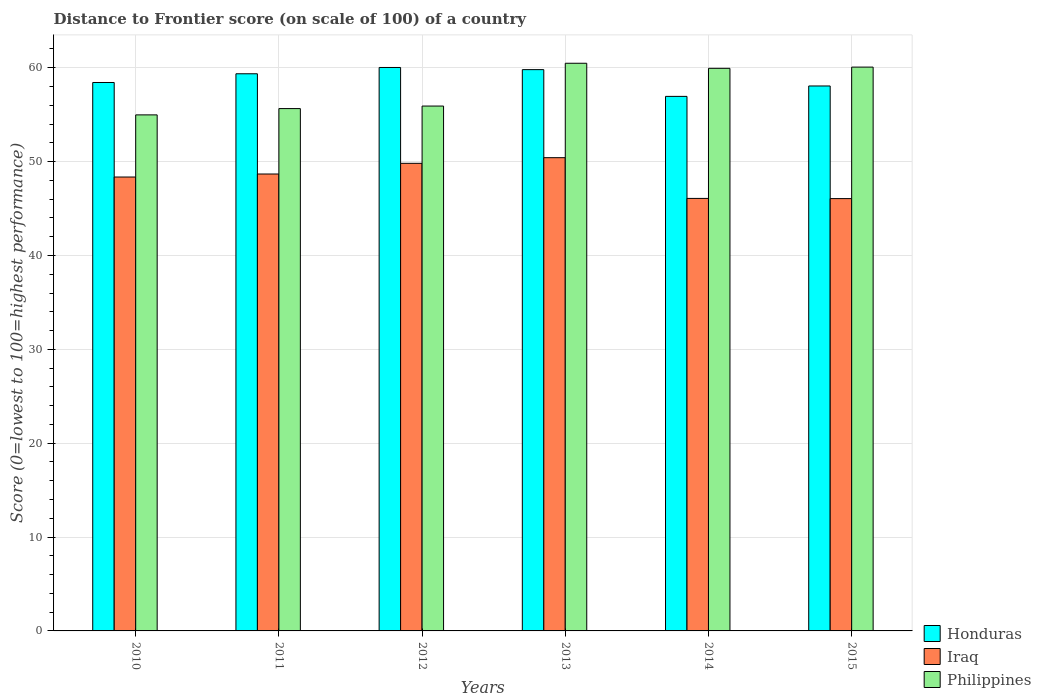How many different coloured bars are there?
Keep it short and to the point. 3. What is the distance to frontier score of in Philippines in 2015?
Your response must be concise. 60.07. Across all years, what is the maximum distance to frontier score of in Iraq?
Your answer should be compact. 50.42. Across all years, what is the minimum distance to frontier score of in Iraq?
Provide a succinct answer. 46.06. In which year was the distance to frontier score of in Iraq maximum?
Provide a short and direct response. 2013. In which year was the distance to frontier score of in Honduras minimum?
Offer a very short reply. 2014. What is the total distance to frontier score of in Philippines in the graph?
Provide a succinct answer. 347.04. What is the difference between the distance to frontier score of in Iraq in 2010 and that in 2013?
Your response must be concise. -2.06. What is the difference between the distance to frontier score of in Philippines in 2011 and the distance to frontier score of in Iraq in 2012?
Keep it short and to the point. 5.83. What is the average distance to frontier score of in Honduras per year?
Offer a terse response. 58.77. In the year 2013, what is the difference between the distance to frontier score of in Iraq and distance to frontier score of in Honduras?
Provide a short and direct response. -9.38. What is the ratio of the distance to frontier score of in Honduras in 2010 to that in 2011?
Make the answer very short. 0.98. Is the distance to frontier score of in Honduras in 2011 less than that in 2015?
Make the answer very short. No. Is the difference between the distance to frontier score of in Iraq in 2010 and 2015 greater than the difference between the distance to frontier score of in Honduras in 2010 and 2015?
Make the answer very short. Yes. What is the difference between the highest and the second highest distance to frontier score of in Philippines?
Provide a short and direct response. 0.41. What does the 2nd bar from the left in 2014 represents?
Provide a short and direct response. Iraq. What does the 2nd bar from the right in 2010 represents?
Ensure brevity in your answer.  Iraq. Are all the bars in the graph horizontal?
Make the answer very short. No. Are the values on the major ticks of Y-axis written in scientific E-notation?
Keep it short and to the point. No. Does the graph contain any zero values?
Keep it short and to the point. No. Where does the legend appear in the graph?
Keep it short and to the point. Bottom right. What is the title of the graph?
Keep it short and to the point. Distance to Frontier score (on scale of 100) of a country. What is the label or title of the Y-axis?
Make the answer very short. Score (0=lowest to 100=highest performance). What is the Score (0=lowest to 100=highest performance) in Honduras in 2010?
Offer a very short reply. 58.43. What is the Score (0=lowest to 100=highest performance) in Iraq in 2010?
Provide a succinct answer. 48.36. What is the Score (0=lowest to 100=highest performance) of Philippines in 2010?
Provide a short and direct response. 54.98. What is the Score (0=lowest to 100=highest performance) in Honduras in 2011?
Offer a terse response. 59.36. What is the Score (0=lowest to 100=highest performance) in Iraq in 2011?
Your answer should be compact. 48.68. What is the Score (0=lowest to 100=highest performance) of Philippines in 2011?
Provide a succinct answer. 55.65. What is the Score (0=lowest to 100=highest performance) of Honduras in 2012?
Ensure brevity in your answer.  60.03. What is the Score (0=lowest to 100=highest performance) in Iraq in 2012?
Offer a terse response. 49.82. What is the Score (0=lowest to 100=highest performance) in Philippines in 2012?
Offer a very short reply. 55.92. What is the Score (0=lowest to 100=highest performance) in Honduras in 2013?
Your response must be concise. 59.8. What is the Score (0=lowest to 100=highest performance) of Iraq in 2013?
Offer a very short reply. 50.42. What is the Score (0=lowest to 100=highest performance) in Philippines in 2013?
Your answer should be very brief. 60.48. What is the Score (0=lowest to 100=highest performance) of Honduras in 2014?
Keep it short and to the point. 56.95. What is the Score (0=lowest to 100=highest performance) of Iraq in 2014?
Provide a succinct answer. 46.08. What is the Score (0=lowest to 100=highest performance) of Philippines in 2014?
Your answer should be very brief. 59.94. What is the Score (0=lowest to 100=highest performance) in Honduras in 2015?
Provide a short and direct response. 58.06. What is the Score (0=lowest to 100=highest performance) in Iraq in 2015?
Provide a short and direct response. 46.06. What is the Score (0=lowest to 100=highest performance) in Philippines in 2015?
Make the answer very short. 60.07. Across all years, what is the maximum Score (0=lowest to 100=highest performance) of Honduras?
Your answer should be very brief. 60.03. Across all years, what is the maximum Score (0=lowest to 100=highest performance) of Iraq?
Provide a succinct answer. 50.42. Across all years, what is the maximum Score (0=lowest to 100=highest performance) of Philippines?
Your response must be concise. 60.48. Across all years, what is the minimum Score (0=lowest to 100=highest performance) in Honduras?
Keep it short and to the point. 56.95. Across all years, what is the minimum Score (0=lowest to 100=highest performance) of Iraq?
Ensure brevity in your answer.  46.06. Across all years, what is the minimum Score (0=lowest to 100=highest performance) in Philippines?
Provide a short and direct response. 54.98. What is the total Score (0=lowest to 100=highest performance) of Honduras in the graph?
Your response must be concise. 352.63. What is the total Score (0=lowest to 100=highest performance) of Iraq in the graph?
Your answer should be very brief. 289.42. What is the total Score (0=lowest to 100=highest performance) of Philippines in the graph?
Offer a very short reply. 347.04. What is the difference between the Score (0=lowest to 100=highest performance) of Honduras in 2010 and that in 2011?
Your answer should be very brief. -0.93. What is the difference between the Score (0=lowest to 100=highest performance) in Iraq in 2010 and that in 2011?
Offer a terse response. -0.32. What is the difference between the Score (0=lowest to 100=highest performance) of Philippines in 2010 and that in 2011?
Your response must be concise. -0.67. What is the difference between the Score (0=lowest to 100=highest performance) of Honduras in 2010 and that in 2012?
Keep it short and to the point. -1.6. What is the difference between the Score (0=lowest to 100=highest performance) of Iraq in 2010 and that in 2012?
Offer a terse response. -1.46. What is the difference between the Score (0=lowest to 100=highest performance) of Philippines in 2010 and that in 2012?
Your answer should be very brief. -0.94. What is the difference between the Score (0=lowest to 100=highest performance) in Honduras in 2010 and that in 2013?
Provide a short and direct response. -1.37. What is the difference between the Score (0=lowest to 100=highest performance) of Iraq in 2010 and that in 2013?
Give a very brief answer. -2.06. What is the difference between the Score (0=lowest to 100=highest performance) of Honduras in 2010 and that in 2014?
Offer a terse response. 1.48. What is the difference between the Score (0=lowest to 100=highest performance) in Iraq in 2010 and that in 2014?
Keep it short and to the point. 2.28. What is the difference between the Score (0=lowest to 100=highest performance) in Philippines in 2010 and that in 2014?
Your response must be concise. -4.96. What is the difference between the Score (0=lowest to 100=highest performance) in Honduras in 2010 and that in 2015?
Make the answer very short. 0.37. What is the difference between the Score (0=lowest to 100=highest performance) of Philippines in 2010 and that in 2015?
Provide a short and direct response. -5.09. What is the difference between the Score (0=lowest to 100=highest performance) of Honduras in 2011 and that in 2012?
Offer a very short reply. -0.67. What is the difference between the Score (0=lowest to 100=highest performance) in Iraq in 2011 and that in 2012?
Offer a terse response. -1.14. What is the difference between the Score (0=lowest to 100=highest performance) in Philippines in 2011 and that in 2012?
Your response must be concise. -0.27. What is the difference between the Score (0=lowest to 100=highest performance) in Honduras in 2011 and that in 2013?
Your response must be concise. -0.44. What is the difference between the Score (0=lowest to 100=highest performance) of Iraq in 2011 and that in 2013?
Offer a terse response. -1.74. What is the difference between the Score (0=lowest to 100=highest performance) of Philippines in 2011 and that in 2013?
Give a very brief answer. -4.83. What is the difference between the Score (0=lowest to 100=highest performance) in Honduras in 2011 and that in 2014?
Provide a short and direct response. 2.41. What is the difference between the Score (0=lowest to 100=highest performance) in Philippines in 2011 and that in 2014?
Offer a very short reply. -4.29. What is the difference between the Score (0=lowest to 100=highest performance) of Honduras in 2011 and that in 2015?
Offer a very short reply. 1.3. What is the difference between the Score (0=lowest to 100=highest performance) of Iraq in 2011 and that in 2015?
Offer a very short reply. 2.62. What is the difference between the Score (0=lowest to 100=highest performance) of Philippines in 2011 and that in 2015?
Offer a very short reply. -4.42. What is the difference between the Score (0=lowest to 100=highest performance) of Honduras in 2012 and that in 2013?
Make the answer very short. 0.23. What is the difference between the Score (0=lowest to 100=highest performance) of Iraq in 2012 and that in 2013?
Your response must be concise. -0.6. What is the difference between the Score (0=lowest to 100=highest performance) in Philippines in 2012 and that in 2013?
Keep it short and to the point. -4.56. What is the difference between the Score (0=lowest to 100=highest performance) of Honduras in 2012 and that in 2014?
Provide a short and direct response. 3.08. What is the difference between the Score (0=lowest to 100=highest performance) in Iraq in 2012 and that in 2014?
Make the answer very short. 3.74. What is the difference between the Score (0=lowest to 100=highest performance) of Philippines in 2012 and that in 2014?
Provide a succinct answer. -4.02. What is the difference between the Score (0=lowest to 100=highest performance) in Honduras in 2012 and that in 2015?
Your answer should be compact. 1.97. What is the difference between the Score (0=lowest to 100=highest performance) of Iraq in 2012 and that in 2015?
Make the answer very short. 3.76. What is the difference between the Score (0=lowest to 100=highest performance) in Philippines in 2012 and that in 2015?
Your answer should be compact. -4.15. What is the difference between the Score (0=lowest to 100=highest performance) of Honduras in 2013 and that in 2014?
Your response must be concise. 2.85. What is the difference between the Score (0=lowest to 100=highest performance) of Iraq in 2013 and that in 2014?
Offer a terse response. 4.34. What is the difference between the Score (0=lowest to 100=highest performance) of Philippines in 2013 and that in 2014?
Make the answer very short. 0.54. What is the difference between the Score (0=lowest to 100=highest performance) of Honduras in 2013 and that in 2015?
Provide a short and direct response. 1.74. What is the difference between the Score (0=lowest to 100=highest performance) in Iraq in 2013 and that in 2015?
Offer a terse response. 4.36. What is the difference between the Score (0=lowest to 100=highest performance) of Philippines in 2013 and that in 2015?
Give a very brief answer. 0.41. What is the difference between the Score (0=lowest to 100=highest performance) in Honduras in 2014 and that in 2015?
Ensure brevity in your answer.  -1.11. What is the difference between the Score (0=lowest to 100=highest performance) of Iraq in 2014 and that in 2015?
Ensure brevity in your answer.  0.02. What is the difference between the Score (0=lowest to 100=highest performance) in Philippines in 2014 and that in 2015?
Your response must be concise. -0.13. What is the difference between the Score (0=lowest to 100=highest performance) in Honduras in 2010 and the Score (0=lowest to 100=highest performance) in Iraq in 2011?
Ensure brevity in your answer.  9.75. What is the difference between the Score (0=lowest to 100=highest performance) of Honduras in 2010 and the Score (0=lowest to 100=highest performance) of Philippines in 2011?
Provide a short and direct response. 2.78. What is the difference between the Score (0=lowest to 100=highest performance) of Iraq in 2010 and the Score (0=lowest to 100=highest performance) of Philippines in 2011?
Provide a succinct answer. -7.29. What is the difference between the Score (0=lowest to 100=highest performance) of Honduras in 2010 and the Score (0=lowest to 100=highest performance) of Iraq in 2012?
Keep it short and to the point. 8.61. What is the difference between the Score (0=lowest to 100=highest performance) of Honduras in 2010 and the Score (0=lowest to 100=highest performance) of Philippines in 2012?
Your response must be concise. 2.51. What is the difference between the Score (0=lowest to 100=highest performance) in Iraq in 2010 and the Score (0=lowest to 100=highest performance) in Philippines in 2012?
Keep it short and to the point. -7.56. What is the difference between the Score (0=lowest to 100=highest performance) in Honduras in 2010 and the Score (0=lowest to 100=highest performance) in Iraq in 2013?
Your answer should be compact. 8.01. What is the difference between the Score (0=lowest to 100=highest performance) of Honduras in 2010 and the Score (0=lowest to 100=highest performance) of Philippines in 2013?
Ensure brevity in your answer.  -2.05. What is the difference between the Score (0=lowest to 100=highest performance) in Iraq in 2010 and the Score (0=lowest to 100=highest performance) in Philippines in 2013?
Give a very brief answer. -12.12. What is the difference between the Score (0=lowest to 100=highest performance) of Honduras in 2010 and the Score (0=lowest to 100=highest performance) of Iraq in 2014?
Your answer should be very brief. 12.35. What is the difference between the Score (0=lowest to 100=highest performance) of Honduras in 2010 and the Score (0=lowest to 100=highest performance) of Philippines in 2014?
Offer a very short reply. -1.51. What is the difference between the Score (0=lowest to 100=highest performance) of Iraq in 2010 and the Score (0=lowest to 100=highest performance) of Philippines in 2014?
Provide a short and direct response. -11.58. What is the difference between the Score (0=lowest to 100=highest performance) in Honduras in 2010 and the Score (0=lowest to 100=highest performance) in Iraq in 2015?
Make the answer very short. 12.37. What is the difference between the Score (0=lowest to 100=highest performance) of Honduras in 2010 and the Score (0=lowest to 100=highest performance) of Philippines in 2015?
Offer a terse response. -1.64. What is the difference between the Score (0=lowest to 100=highest performance) of Iraq in 2010 and the Score (0=lowest to 100=highest performance) of Philippines in 2015?
Your answer should be very brief. -11.71. What is the difference between the Score (0=lowest to 100=highest performance) in Honduras in 2011 and the Score (0=lowest to 100=highest performance) in Iraq in 2012?
Give a very brief answer. 9.54. What is the difference between the Score (0=lowest to 100=highest performance) in Honduras in 2011 and the Score (0=lowest to 100=highest performance) in Philippines in 2012?
Ensure brevity in your answer.  3.44. What is the difference between the Score (0=lowest to 100=highest performance) of Iraq in 2011 and the Score (0=lowest to 100=highest performance) of Philippines in 2012?
Ensure brevity in your answer.  -7.24. What is the difference between the Score (0=lowest to 100=highest performance) of Honduras in 2011 and the Score (0=lowest to 100=highest performance) of Iraq in 2013?
Provide a succinct answer. 8.94. What is the difference between the Score (0=lowest to 100=highest performance) in Honduras in 2011 and the Score (0=lowest to 100=highest performance) in Philippines in 2013?
Keep it short and to the point. -1.12. What is the difference between the Score (0=lowest to 100=highest performance) of Iraq in 2011 and the Score (0=lowest to 100=highest performance) of Philippines in 2013?
Your answer should be compact. -11.8. What is the difference between the Score (0=lowest to 100=highest performance) in Honduras in 2011 and the Score (0=lowest to 100=highest performance) in Iraq in 2014?
Offer a terse response. 13.28. What is the difference between the Score (0=lowest to 100=highest performance) in Honduras in 2011 and the Score (0=lowest to 100=highest performance) in Philippines in 2014?
Provide a short and direct response. -0.58. What is the difference between the Score (0=lowest to 100=highest performance) of Iraq in 2011 and the Score (0=lowest to 100=highest performance) of Philippines in 2014?
Make the answer very short. -11.26. What is the difference between the Score (0=lowest to 100=highest performance) in Honduras in 2011 and the Score (0=lowest to 100=highest performance) in Iraq in 2015?
Your response must be concise. 13.3. What is the difference between the Score (0=lowest to 100=highest performance) in Honduras in 2011 and the Score (0=lowest to 100=highest performance) in Philippines in 2015?
Offer a terse response. -0.71. What is the difference between the Score (0=lowest to 100=highest performance) of Iraq in 2011 and the Score (0=lowest to 100=highest performance) of Philippines in 2015?
Provide a succinct answer. -11.39. What is the difference between the Score (0=lowest to 100=highest performance) of Honduras in 2012 and the Score (0=lowest to 100=highest performance) of Iraq in 2013?
Keep it short and to the point. 9.61. What is the difference between the Score (0=lowest to 100=highest performance) of Honduras in 2012 and the Score (0=lowest to 100=highest performance) of Philippines in 2013?
Your answer should be compact. -0.45. What is the difference between the Score (0=lowest to 100=highest performance) in Iraq in 2012 and the Score (0=lowest to 100=highest performance) in Philippines in 2013?
Offer a very short reply. -10.66. What is the difference between the Score (0=lowest to 100=highest performance) of Honduras in 2012 and the Score (0=lowest to 100=highest performance) of Iraq in 2014?
Provide a succinct answer. 13.95. What is the difference between the Score (0=lowest to 100=highest performance) of Honduras in 2012 and the Score (0=lowest to 100=highest performance) of Philippines in 2014?
Make the answer very short. 0.09. What is the difference between the Score (0=lowest to 100=highest performance) of Iraq in 2012 and the Score (0=lowest to 100=highest performance) of Philippines in 2014?
Offer a very short reply. -10.12. What is the difference between the Score (0=lowest to 100=highest performance) of Honduras in 2012 and the Score (0=lowest to 100=highest performance) of Iraq in 2015?
Provide a succinct answer. 13.97. What is the difference between the Score (0=lowest to 100=highest performance) of Honduras in 2012 and the Score (0=lowest to 100=highest performance) of Philippines in 2015?
Provide a short and direct response. -0.04. What is the difference between the Score (0=lowest to 100=highest performance) of Iraq in 2012 and the Score (0=lowest to 100=highest performance) of Philippines in 2015?
Provide a succinct answer. -10.25. What is the difference between the Score (0=lowest to 100=highest performance) in Honduras in 2013 and the Score (0=lowest to 100=highest performance) in Iraq in 2014?
Your answer should be very brief. 13.72. What is the difference between the Score (0=lowest to 100=highest performance) of Honduras in 2013 and the Score (0=lowest to 100=highest performance) of Philippines in 2014?
Offer a terse response. -0.14. What is the difference between the Score (0=lowest to 100=highest performance) in Iraq in 2013 and the Score (0=lowest to 100=highest performance) in Philippines in 2014?
Provide a short and direct response. -9.52. What is the difference between the Score (0=lowest to 100=highest performance) in Honduras in 2013 and the Score (0=lowest to 100=highest performance) in Iraq in 2015?
Give a very brief answer. 13.74. What is the difference between the Score (0=lowest to 100=highest performance) in Honduras in 2013 and the Score (0=lowest to 100=highest performance) in Philippines in 2015?
Keep it short and to the point. -0.27. What is the difference between the Score (0=lowest to 100=highest performance) in Iraq in 2013 and the Score (0=lowest to 100=highest performance) in Philippines in 2015?
Offer a very short reply. -9.65. What is the difference between the Score (0=lowest to 100=highest performance) in Honduras in 2014 and the Score (0=lowest to 100=highest performance) in Iraq in 2015?
Keep it short and to the point. 10.89. What is the difference between the Score (0=lowest to 100=highest performance) in Honduras in 2014 and the Score (0=lowest to 100=highest performance) in Philippines in 2015?
Keep it short and to the point. -3.12. What is the difference between the Score (0=lowest to 100=highest performance) in Iraq in 2014 and the Score (0=lowest to 100=highest performance) in Philippines in 2015?
Keep it short and to the point. -13.99. What is the average Score (0=lowest to 100=highest performance) of Honduras per year?
Your response must be concise. 58.77. What is the average Score (0=lowest to 100=highest performance) in Iraq per year?
Give a very brief answer. 48.24. What is the average Score (0=lowest to 100=highest performance) of Philippines per year?
Keep it short and to the point. 57.84. In the year 2010, what is the difference between the Score (0=lowest to 100=highest performance) in Honduras and Score (0=lowest to 100=highest performance) in Iraq?
Keep it short and to the point. 10.07. In the year 2010, what is the difference between the Score (0=lowest to 100=highest performance) of Honduras and Score (0=lowest to 100=highest performance) of Philippines?
Offer a terse response. 3.45. In the year 2010, what is the difference between the Score (0=lowest to 100=highest performance) of Iraq and Score (0=lowest to 100=highest performance) of Philippines?
Provide a short and direct response. -6.62. In the year 2011, what is the difference between the Score (0=lowest to 100=highest performance) of Honduras and Score (0=lowest to 100=highest performance) of Iraq?
Keep it short and to the point. 10.68. In the year 2011, what is the difference between the Score (0=lowest to 100=highest performance) of Honduras and Score (0=lowest to 100=highest performance) of Philippines?
Your answer should be compact. 3.71. In the year 2011, what is the difference between the Score (0=lowest to 100=highest performance) of Iraq and Score (0=lowest to 100=highest performance) of Philippines?
Give a very brief answer. -6.97. In the year 2012, what is the difference between the Score (0=lowest to 100=highest performance) in Honduras and Score (0=lowest to 100=highest performance) in Iraq?
Provide a short and direct response. 10.21. In the year 2012, what is the difference between the Score (0=lowest to 100=highest performance) of Honduras and Score (0=lowest to 100=highest performance) of Philippines?
Keep it short and to the point. 4.11. In the year 2012, what is the difference between the Score (0=lowest to 100=highest performance) in Iraq and Score (0=lowest to 100=highest performance) in Philippines?
Keep it short and to the point. -6.1. In the year 2013, what is the difference between the Score (0=lowest to 100=highest performance) in Honduras and Score (0=lowest to 100=highest performance) in Iraq?
Make the answer very short. 9.38. In the year 2013, what is the difference between the Score (0=lowest to 100=highest performance) in Honduras and Score (0=lowest to 100=highest performance) in Philippines?
Give a very brief answer. -0.68. In the year 2013, what is the difference between the Score (0=lowest to 100=highest performance) of Iraq and Score (0=lowest to 100=highest performance) of Philippines?
Provide a succinct answer. -10.06. In the year 2014, what is the difference between the Score (0=lowest to 100=highest performance) of Honduras and Score (0=lowest to 100=highest performance) of Iraq?
Ensure brevity in your answer.  10.87. In the year 2014, what is the difference between the Score (0=lowest to 100=highest performance) of Honduras and Score (0=lowest to 100=highest performance) of Philippines?
Keep it short and to the point. -2.99. In the year 2014, what is the difference between the Score (0=lowest to 100=highest performance) of Iraq and Score (0=lowest to 100=highest performance) of Philippines?
Give a very brief answer. -13.86. In the year 2015, what is the difference between the Score (0=lowest to 100=highest performance) in Honduras and Score (0=lowest to 100=highest performance) in Iraq?
Offer a very short reply. 12. In the year 2015, what is the difference between the Score (0=lowest to 100=highest performance) in Honduras and Score (0=lowest to 100=highest performance) in Philippines?
Make the answer very short. -2.01. In the year 2015, what is the difference between the Score (0=lowest to 100=highest performance) of Iraq and Score (0=lowest to 100=highest performance) of Philippines?
Ensure brevity in your answer.  -14.01. What is the ratio of the Score (0=lowest to 100=highest performance) of Honduras in 2010 to that in 2011?
Provide a short and direct response. 0.98. What is the ratio of the Score (0=lowest to 100=highest performance) of Iraq in 2010 to that in 2011?
Offer a very short reply. 0.99. What is the ratio of the Score (0=lowest to 100=highest performance) in Philippines in 2010 to that in 2011?
Ensure brevity in your answer.  0.99. What is the ratio of the Score (0=lowest to 100=highest performance) of Honduras in 2010 to that in 2012?
Offer a terse response. 0.97. What is the ratio of the Score (0=lowest to 100=highest performance) in Iraq in 2010 to that in 2012?
Your response must be concise. 0.97. What is the ratio of the Score (0=lowest to 100=highest performance) of Philippines in 2010 to that in 2012?
Give a very brief answer. 0.98. What is the ratio of the Score (0=lowest to 100=highest performance) in Honduras in 2010 to that in 2013?
Ensure brevity in your answer.  0.98. What is the ratio of the Score (0=lowest to 100=highest performance) in Iraq in 2010 to that in 2013?
Keep it short and to the point. 0.96. What is the ratio of the Score (0=lowest to 100=highest performance) in Iraq in 2010 to that in 2014?
Make the answer very short. 1.05. What is the ratio of the Score (0=lowest to 100=highest performance) in Philippines in 2010 to that in 2014?
Ensure brevity in your answer.  0.92. What is the ratio of the Score (0=lowest to 100=highest performance) of Honduras in 2010 to that in 2015?
Provide a short and direct response. 1.01. What is the ratio of the Score (0=lowest to 100=highest performance) in Iraq in 2010 to that in 2015?
Your answer should be compact. 1.05. What is the ratio of the Score (0=lowest to 100=highest performance) of Philippines in 2010 to that in 2015?
Provide a short and direct response. 0.92. What is the ratio of the Score (0=lowest to 100=highest performance) of Iraq in 2011 to that in 2012?
Offer a very short reply. 0.98. What is the ratio of the Score (0=lowest to 100=highest performance) in Honduras in 2011 to that in 2013?
Your answer should be very brief. 0.99. What is the ratio of the Score (0=lowest to 100=highest performance) in Iraq in 2011 to that in 2013?
Your response must be concise. 0.97. What is the ratio of the Score (0=lowest to 100=highest performance) of Philippines in 2011 to that in 2013?
Provide a short and direct response. 0.92. What is the ratio of the Score (0=lowest to 100=highest performance) in Honduras in 2011 to that in 2014?
Your answer should be compact. 1.04. What is the ratio of the Score (0=lowest to 100=highest performance) in Iraq in 2011 to that in 2014?
Provide a short and direct response. 1.06. What is the ratio of the Score (0=lowest to 100=highest performance) of Philippines in 2011 to that in 2014?
Provide a succinct answer. 0.93. What is the ratio of the Score (0=lowest to 100=highest performance) of Honduras in 2011 to that in 2015?
Give a very brief answer. 1.02. What is the ratio of the Score (0=lowest to 100=highest performance) in Iraq in 2011 to that in 2015?
Ensure brevity in your answer.  1.06. What is the ratio of the Score (0=lowest to 100=highest performance) in Philippines in 2011 to that in 2015?
Ensure brevity in your answer.  0.93. What is the ratio of the Score (0=lowest to 100=highest performance) of Honduras in 2012 to that in 2013?
Your answer should be very brief. 1. What is the ratio of the Score (0=lowest to 100=highest performance) in Philippines in 2012 to that in 2013?
Provide a succinct answer. 0.92. What is the ratio of the Score (0=lowest to 100=highest performance) in Honduras in 2012 to that in 2014?
Your response must be concise. 1.05. What is the ratio of the Score (0=lowest to 100=highest performance) of Iraq in 2012 to that in 2014?
Your answer should be very brief. 1.08. What is the ratio of the Score (0=lowest to 100=highest performance) of Philippines in 2012 to that in 2014?
Your response must be concise. 0.93. What is the ratio of the Score (0=lowest to 100=highest performance) in Honduras in 2012 to that in 2015?
Give a very brief answer. 1.03. What is the ratio of the Score (0=lowest to 100=highest performance) of Iraq in 2012 to that in 2015?
Offer a very short reply. 1.08. What is the ratio of the Score (0=lowest to 100=highest performance) in Philippines in 2012 to that in 2015?
Provide a short and direct response. 0.93. What is the ratio of the Score (0=lowest to 100=highest performance) in Honduras in 2013 to that in 2014?
Offer a very short reply. 1.05. What is the ratio of the Score (0=lowest to 100=highest performance) in Iraq in 2013 to that in 2014?
Offer a terse response. 1.09. What is the ratio of the Score (0=lowest to 100=highest performance) in Philippines in 2013 to that in 2014?
Your response must be concise. 1.01. What is the ratio of the Score (0=lowest to 100=highest performance) in Iraq in 2013 to that in 2015?
Ensure brevity in your answer.  1.09. What is the ratio of the Score (0=lowest to 100=highest performance) in Philippines in 2013 to that in 2015?
Provide a short and direct response. 1.01. What is the ratio of the Score (0=lowest to 100=highest performance) of Honduras in 2014 to that in 2015?
Your answer should be very brief. 0.98. What is the ratio of the Score (0=lowest to 100=highest performance) of Philippines in 2014 to that in 2015?
Your answer should be compact. 1. What is the difference between the highest and the second highest Score (0=lowest to 100=highest performance) in Honduras?
Give a very brief answer. 0.23. What is the difference between the highest and the second highest Score (0=lowest to 100=highest performance) in Iraq?
Give a very brief answer. 0.6. What is the difference between the highest and the second highest Score (0=lowest to 100=highest performance) in Philippines?
Ensure brevity in your answer.  0.41. What is the difference between the highest and the lowest Score (0=lowest to 100=highest performance) in Honduras?
Give a very brief answer. 3.08. What is the difference between the highest and the lowest Score (0=lowest to 100=highest performance) of Iraq?
Your answer should be very brief. 4.36. What is the difference between the highest and the lowest Score (0=lowest to 100=highest performance) of Philippines?
Make the answer very short. 5.5. 